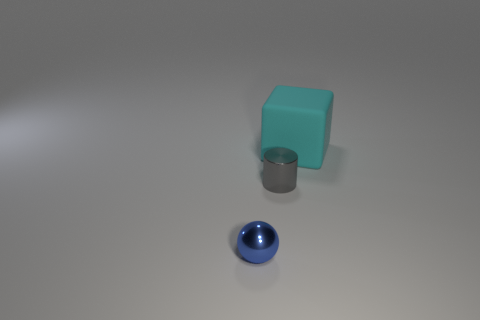What colors are present in the objects in the image? The objects feature distinct colors. The large cube is a teal or turquoise shade, the cylinder has a metallic silver color, and the sphere is a rich blue. Do the shapes of these objects tell us anything about their use? The shapes are simplistic and basic geometric forms which do not inherently indicate specific uses, but their simplicity suggests they could be educational models for demonstrating geometry or perhaps decorative pieces. 